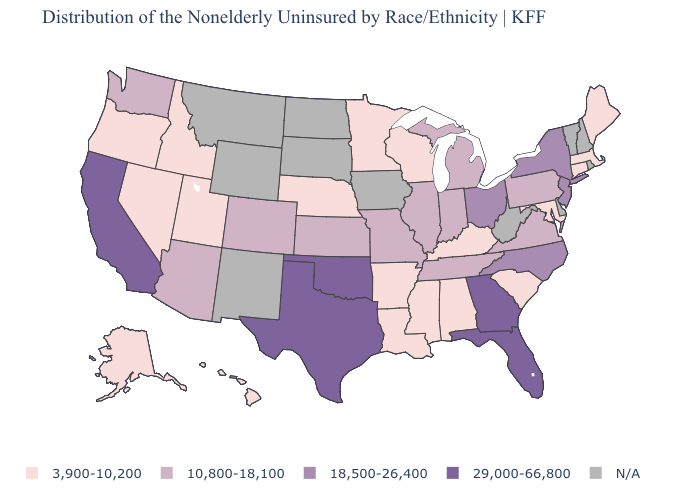What is the lowest value in the USA?
Keep it brief. 3,900-10,200. Which states have the highest value in the USA?
Concise answer only. California, Florida, Georgia, Oklahoma, Texas. Does Hawaii have the lowest value in the USA?
Keep it brief. Yes. What is the value of Wyoming?
Answer briefly. N/A. What is the value of New Jersey?
Write a very short answer. 18,500-26,400. What is the value of Arizona?
Be succinct. 10,800-18,100. Does California have the highest value in the USA?
Short answer required. Yes. What is the lowest value in the USA?
Write a very short answer. 3,900-10,200. Is the legend a continuous bar?
Concise answer only. No. Name the states that have a value in the range 10,800-18,100?
Concise answer only. Arizona, Colorado, Illinois, Indiana, Kansas, Michigan, Missouri, Pennsylvania, Tennessee, Virginia, Washington. What is the value of Hawaii?
Keep it brief. 3,900-10,200. Among the states that border Idaho , which have the lowest value?
Concise answer only. Nevada, Oregon, Utah. Among the states that border Oklahoma , which have the lowest value?
Short answer required. Arkansas. What is the value of Hawaii?
Answer briefly. 3,900-10,200. 